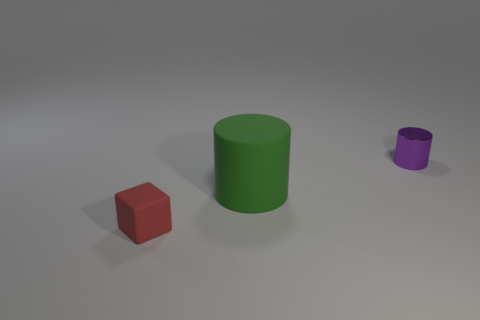What materials do the objects in the image appear to be made of? The objects in the image, based on their visual characteristics, could be interpreted as being made of different types of materials. The red cube has a matte finish which may suggest a clay-like or plastic material, the green cylinder appears to have a slightly reflective surface indicating a painted metal or plastic, while the purple cylinder might be made of a shiny metallic or polished plastic material due to its reflective quality. 